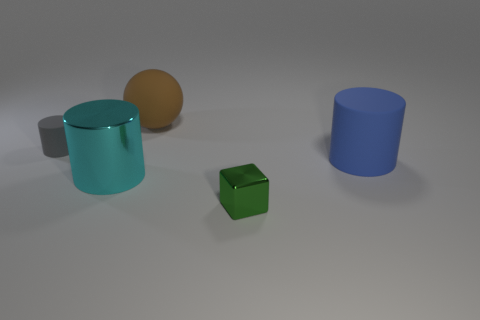Subtract all large blue cylinders. How many cylinders are left? 2 Subtract all blue cylinders. How many cylinders are left? 2 Add 3 cyan things. How many objects exist? 8 Subtract 2 cylinders. How many cylinders are left? 1 Subtract all large objects. Subtract all cubes. How many objects are left? 1 Add 4 large cylinders. How many large cylinders are left? 6 Add 1 tiny cylinders. How many tiny cylinders exist? 2 Subtract 0 yellow balls. How many objects are left? 5 Subtract all cylinders. How many objects are left? 2 Subtract all red cylinders. Subtract all yellow cubes. How many cylinders are left? 3 